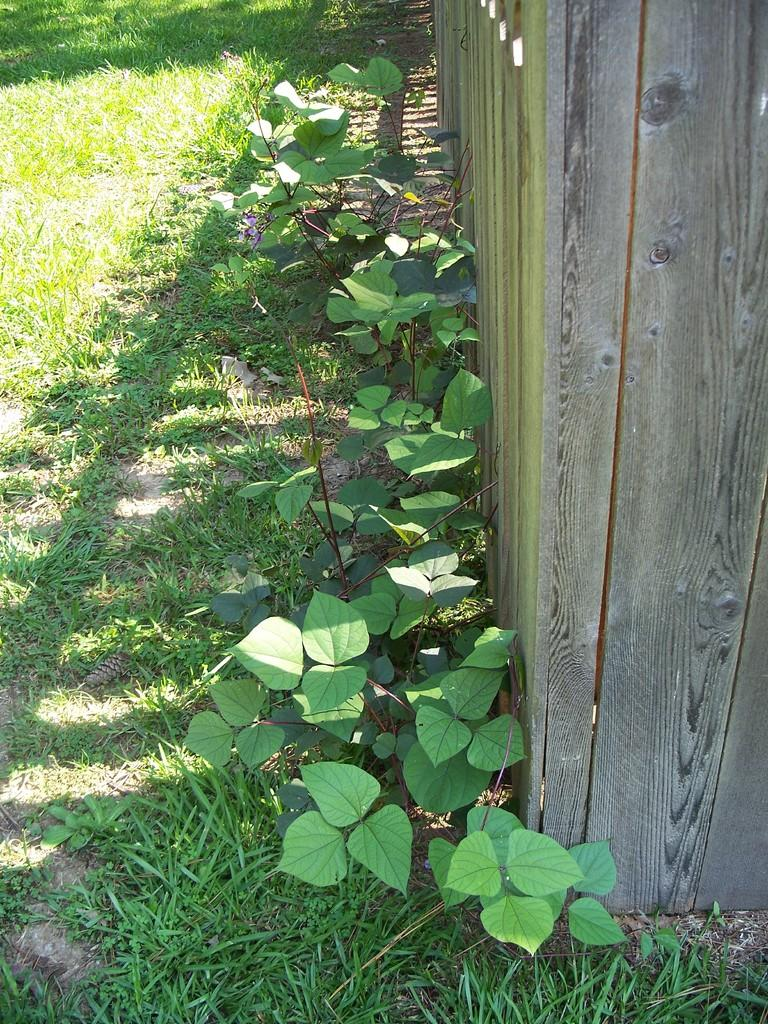What type of wooden object can be seen on the right side of the image? There is a wooden object that looks like a wall on the right side of the image. What other elements are present in the image besides the wooden object? There are plants and grass on the ground in the image. How many lizards can be seen crawling on the wooden object in the image? There are no lizards present in the image; it only features a wooden object, plants, and grass. 